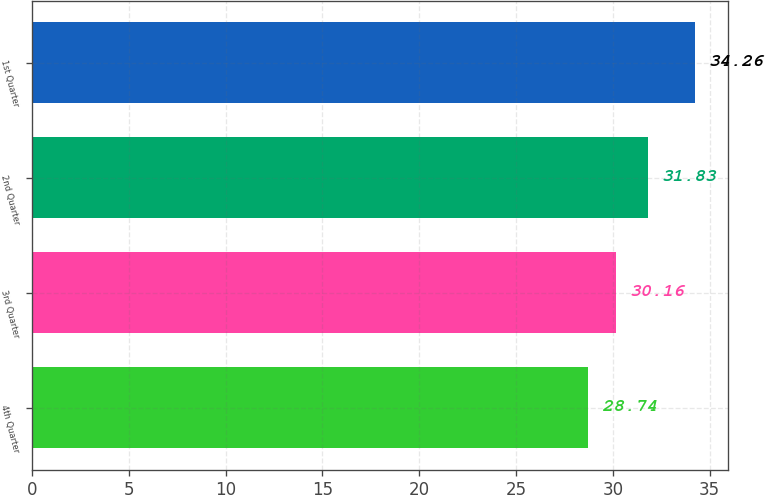Convert chart. <chart><loc_0><loc_0><loc_500><loc_500><bar_chart><fcel>4th Quarter<fcel>3rd Quarter<fcel>2nd Quarter<fcel>1st Quarter<nl><fcel>28.74<fcel>30.16<fcel>31.83<fcel>34.26<nl></chart> 